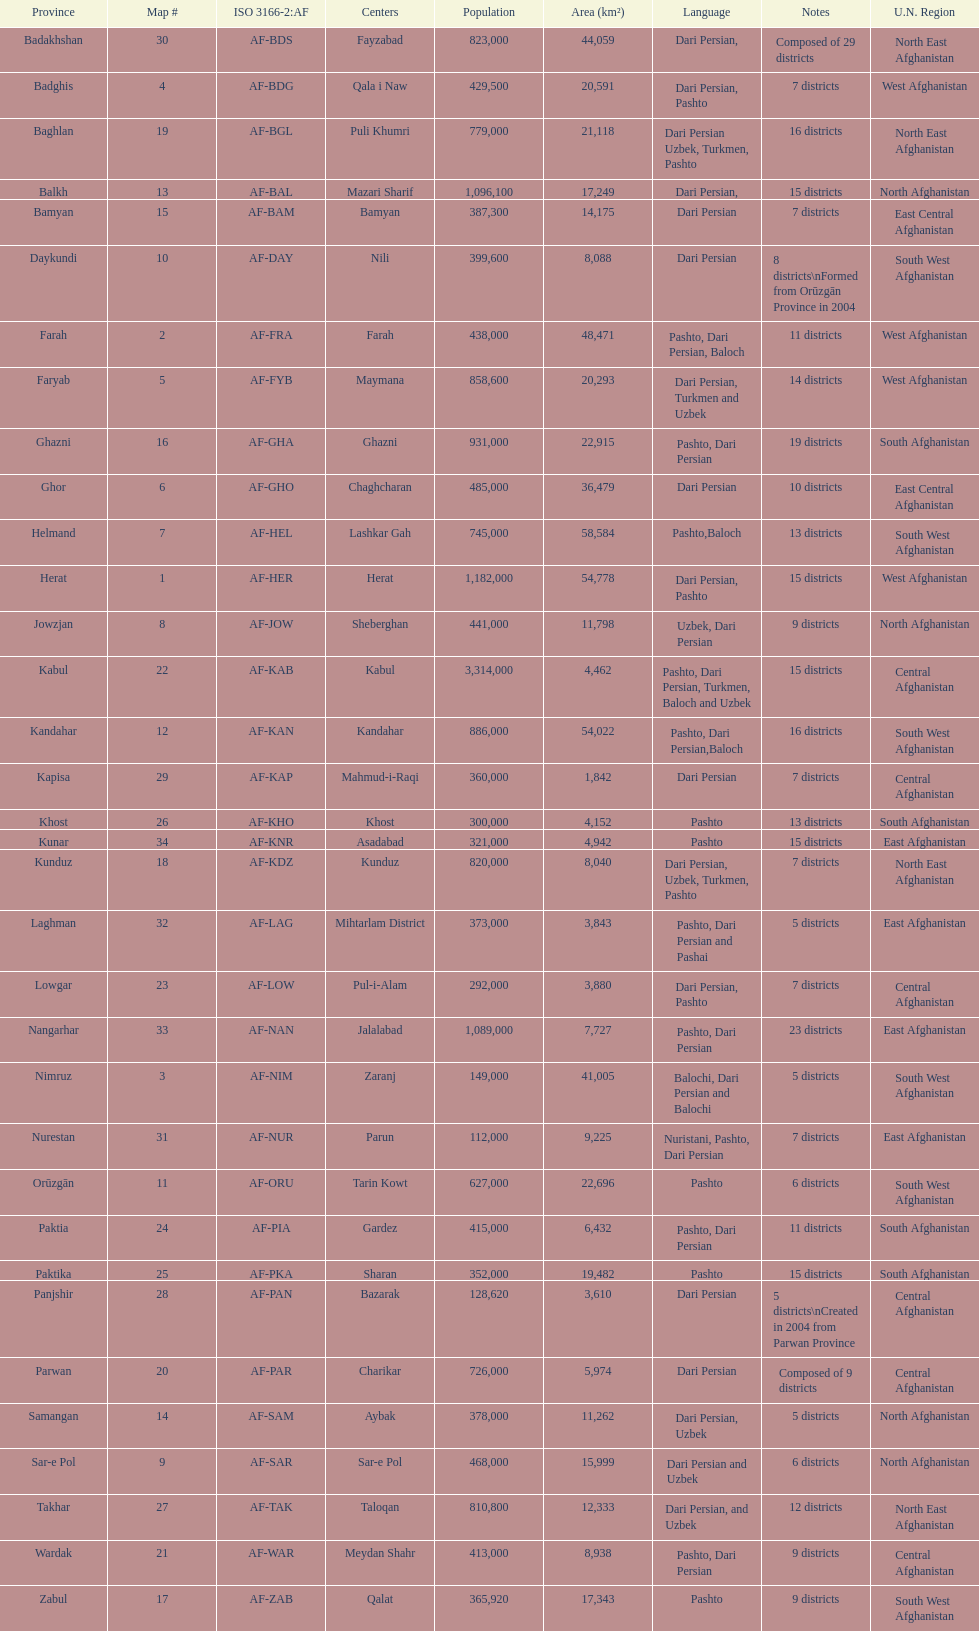Which region has the highest number of districts? Badakhshan. 